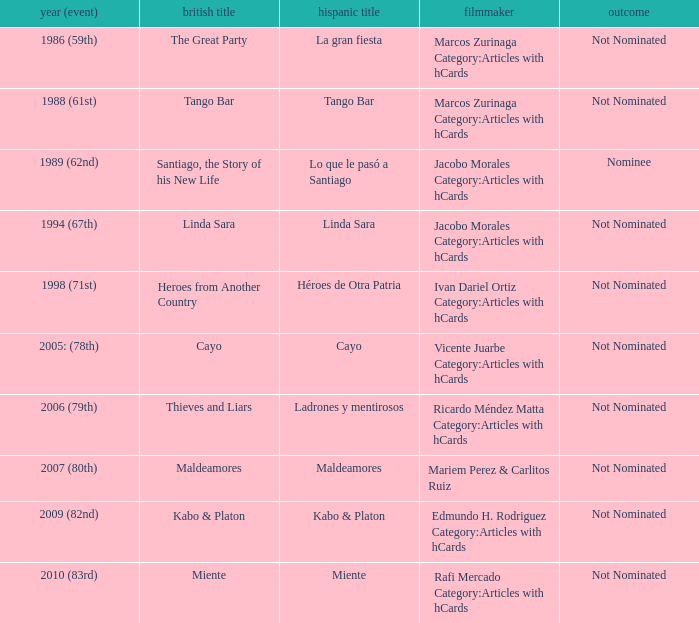What was the English title of Ladrones Y Mentirosos? Thieves and Liars. 